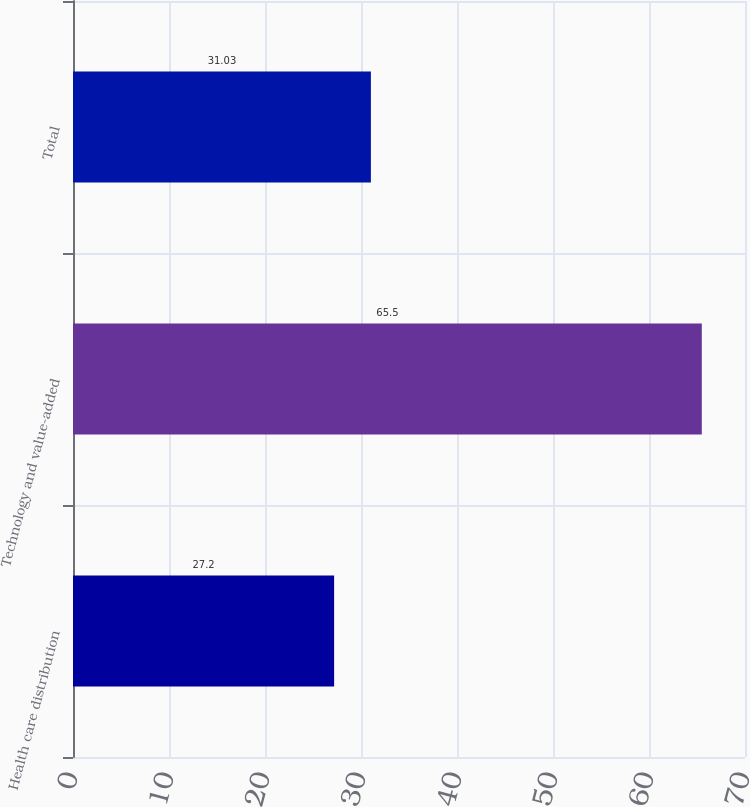Convert chart to OTSL. <chart><loc_0><loc_0><loc_500><loc_500><bar_chart><fcel>Health care distribution<fcel>Technology and value-added<fcel>Total<nl><fcel>27.2<fcel>65.5<fcel>31.03<nl></chart> 